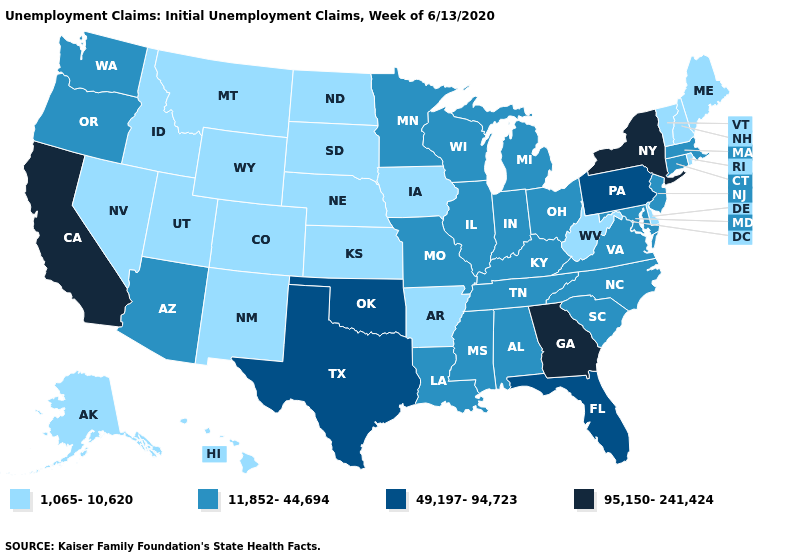Among the states that border Nebraska , does Colorado have the lowest value?
Keep it brief. Yes. What is the value of Delaware?
Write a very short answer. 1,065-10,620. Which states have the lowest value in the USA?
Short answer required. Alaska, Arkansas, Colorado, Delaware, Hawaii, Idaho, Iowa, Kansas, Maine, Montana, Nebraska, Nevada, New Hampshire, New Mexico, North Dakota, Rhode Island, South Dakota, Utah, Vermont, West Virginia, Wyoming. Among the states that border New Mexico , does Utah have the lowest value?
Concise answer only. Yes. Among the states that border Maryland , does Delaware have the highest value?
Write a very short answer. No. Does Mississippi have the highest value in the USA?
Write a very short answer. No. Among the states that border Massachusetts , which have the highest value?
Keep it brief. New York. Does New Hampshire have the lowest value in the Northeast?
Give a very brief answer. Yes. Among the states that border New Mexico , which have the highest value?
Give a very brief answer. Oklahoma, Texas. Name the states that have a value in the range 11,852-44,694?
Give a very brief answer. Alabama, Arizona, Connecticut, Illinois, Indiana, Kentucky, Louisiana, Maryland, Massachusetts, Michigan, Minnesota, Mississippi, Missouri, New Jersey, North Carolina, Ohio, Oregon, South Carolina, Tennessee, Virginia, Washington, Wisconsin. How many symbols are there in the legend?
Short answer required. 4. Does the first symbol in the legend represent the smallest category?
Answer briefly. Yes. Among the states that border Mississippi , which have the lowest value?
Be succinct. Arkansas. What is the highest value in the West ?
Be succinct. 95,150-241,424. What is the value of Michigan?
Answer briefly. 11,852-44,694. 